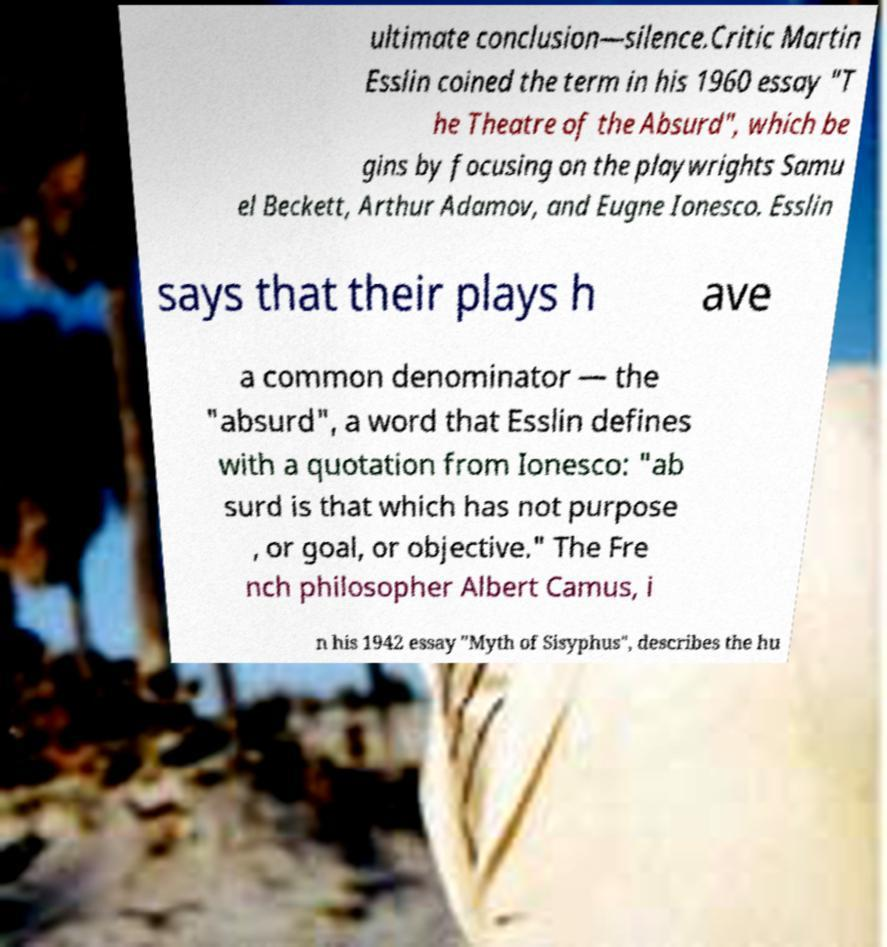Can you accurately transcribe the text from the provided image for me? ultimate conclusion—silence.Critic Martin Esslin coined the term in his 1960 essay "T he Theatre of the Absurd", which be gins by focusing on the playwrights Samu el Beckett, Arthur Adamov, and Eugne Ionesco. Esslin says that their plays h ave a common denominator — the "absurd", a word that Esslin defines with a quotation from Ionesco: "ab surd is that which has not purpose , or goal, or objective." The Fre nch philosopher Albert Camus, i n his 1942 essay "Myth of Sisyphus", describes the hu 